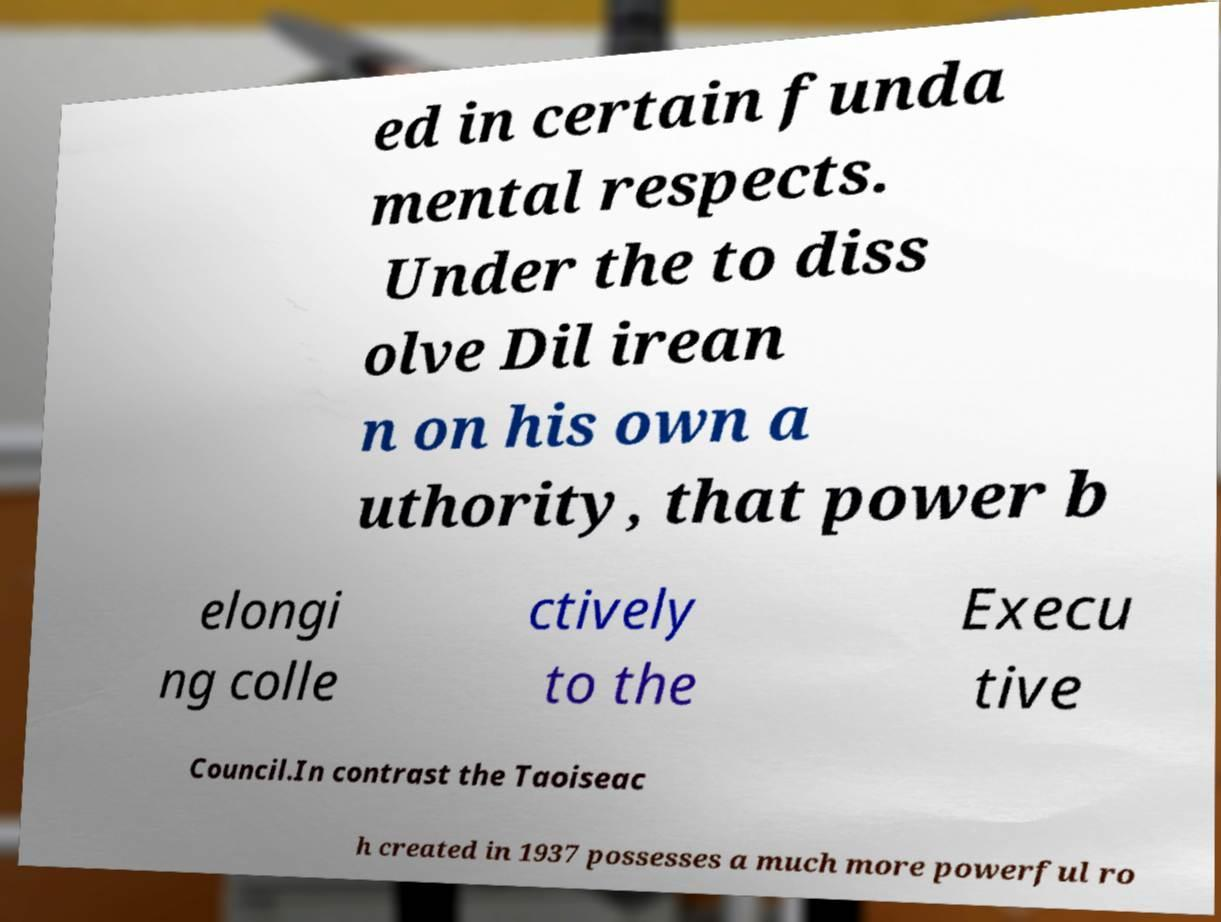Please identify and transcribe the text found in this image. ed in certain funda mental respects. Under the to diss olve Dil irean n on his own a uthority, that power b elongi ng colle ctively to the Execu tive Council.In contrast the Taoiseac h created in 1937 possesses a much more powerful ro 